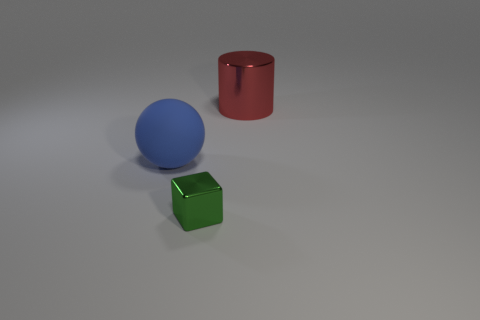Do the red cylinder and the object left of the metallic block have the same material?
Give a very brief answer. No. There is a large object that is behind the large object that is in front of the red metallic cylinder; what number of things are on the right side of it?
Your answer should be very brief. 0. How many cyan objects are either big matte spheres or big cylinders?
Your answer should be compact. 0. There is a shiny object that is on the left side of the red object; what shape is it?
Your answer should be very brief. Cube. There is a rubber ball that is the same size as the metallic cylinder; what is its color?
Your answer should be very brief. Blue. Is the shape of the green shiny object the same as the big metal thing behind the tiny thing?
Offer a very short reply. No. There is a thing in front of the big thing that is left of the large thing that is right of the blue rubber ball; what is it made of?
Your answer should be compact. Metal. What number of tiny things are purple metallic blocks or blue matte objects?
Offer a terse response. 0. How many other objects are there of the same size as the shiny cube?
Ensure brevity in your answer.  0. There is a metallic object that is in front of the large red thing; is its shape the same as the red metallic thing?
Make the answer very short. No. 